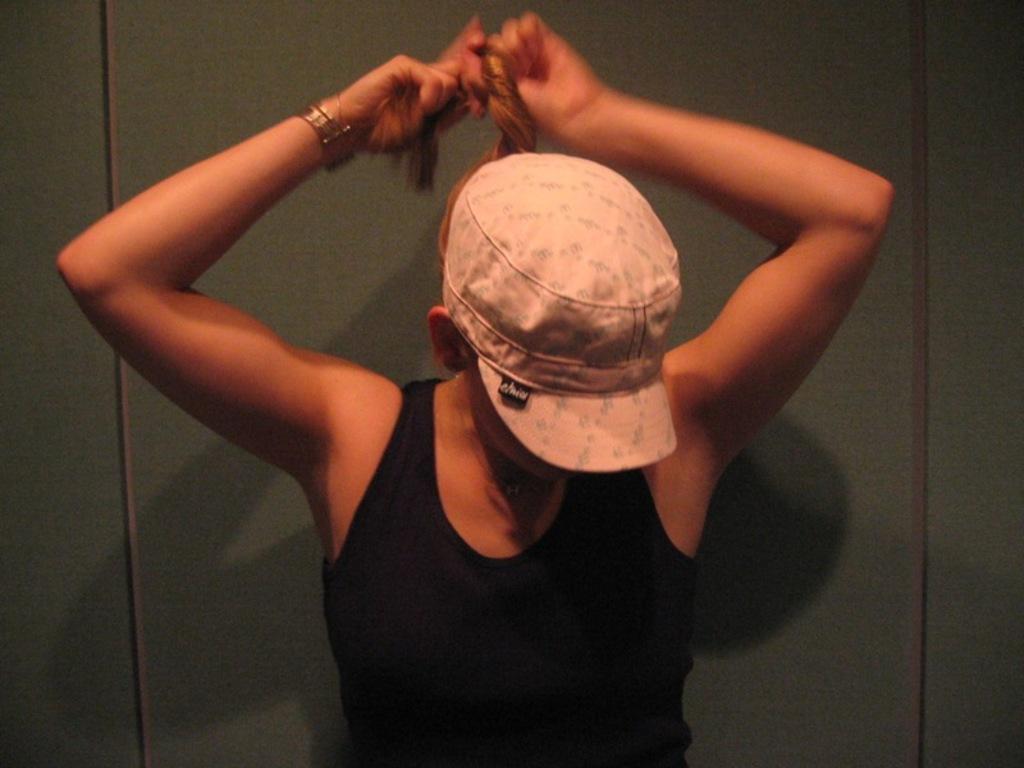In one or two sentences, can you explain what this image depicts? In this picture we can see a woman. Background is green in color. 